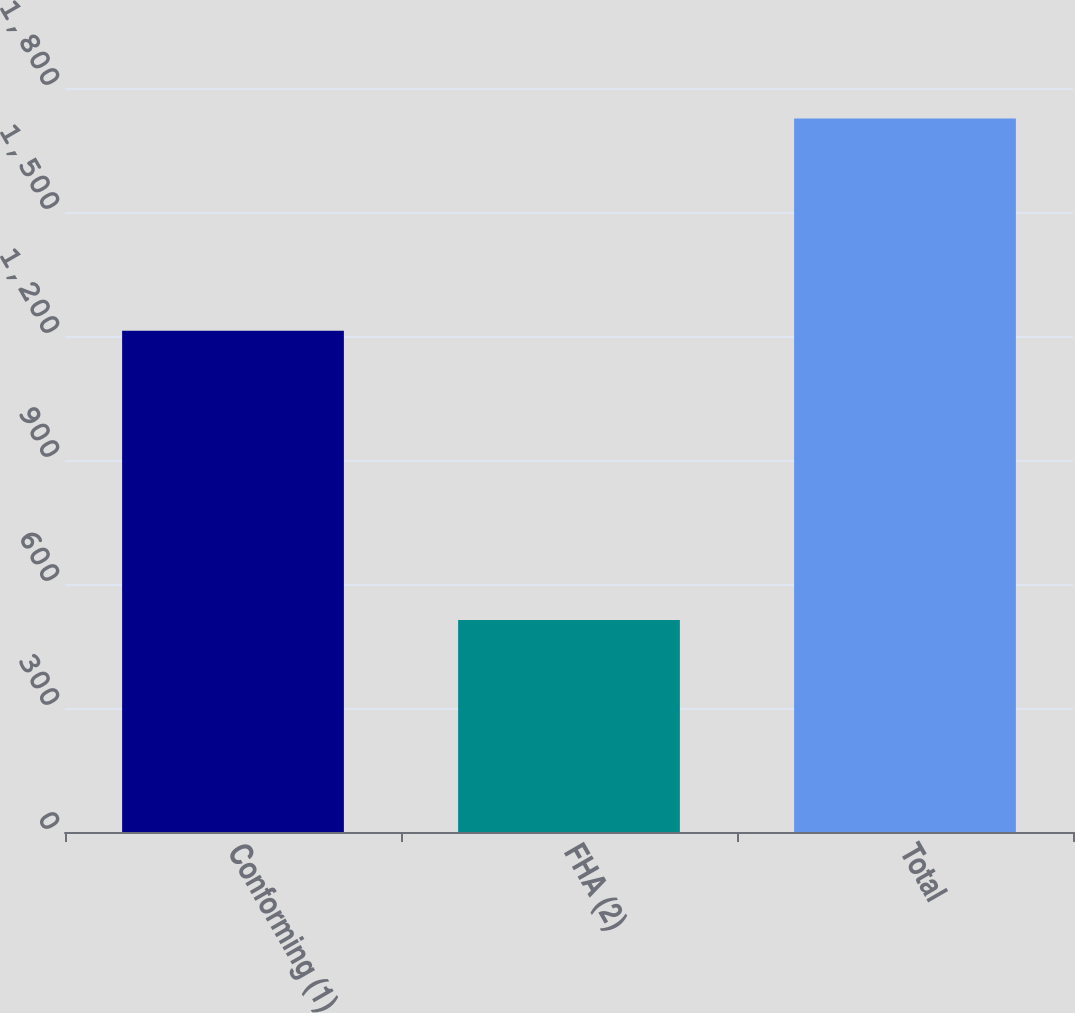<chart> <loc_0><loc_0><loc_500><loc_500><bar_chart><fcel>Conforming (1)<fcel>FHA (2)<fcel>Total<nl><fcel>1213<fcel>513<fcel>1726<nl></chart> 